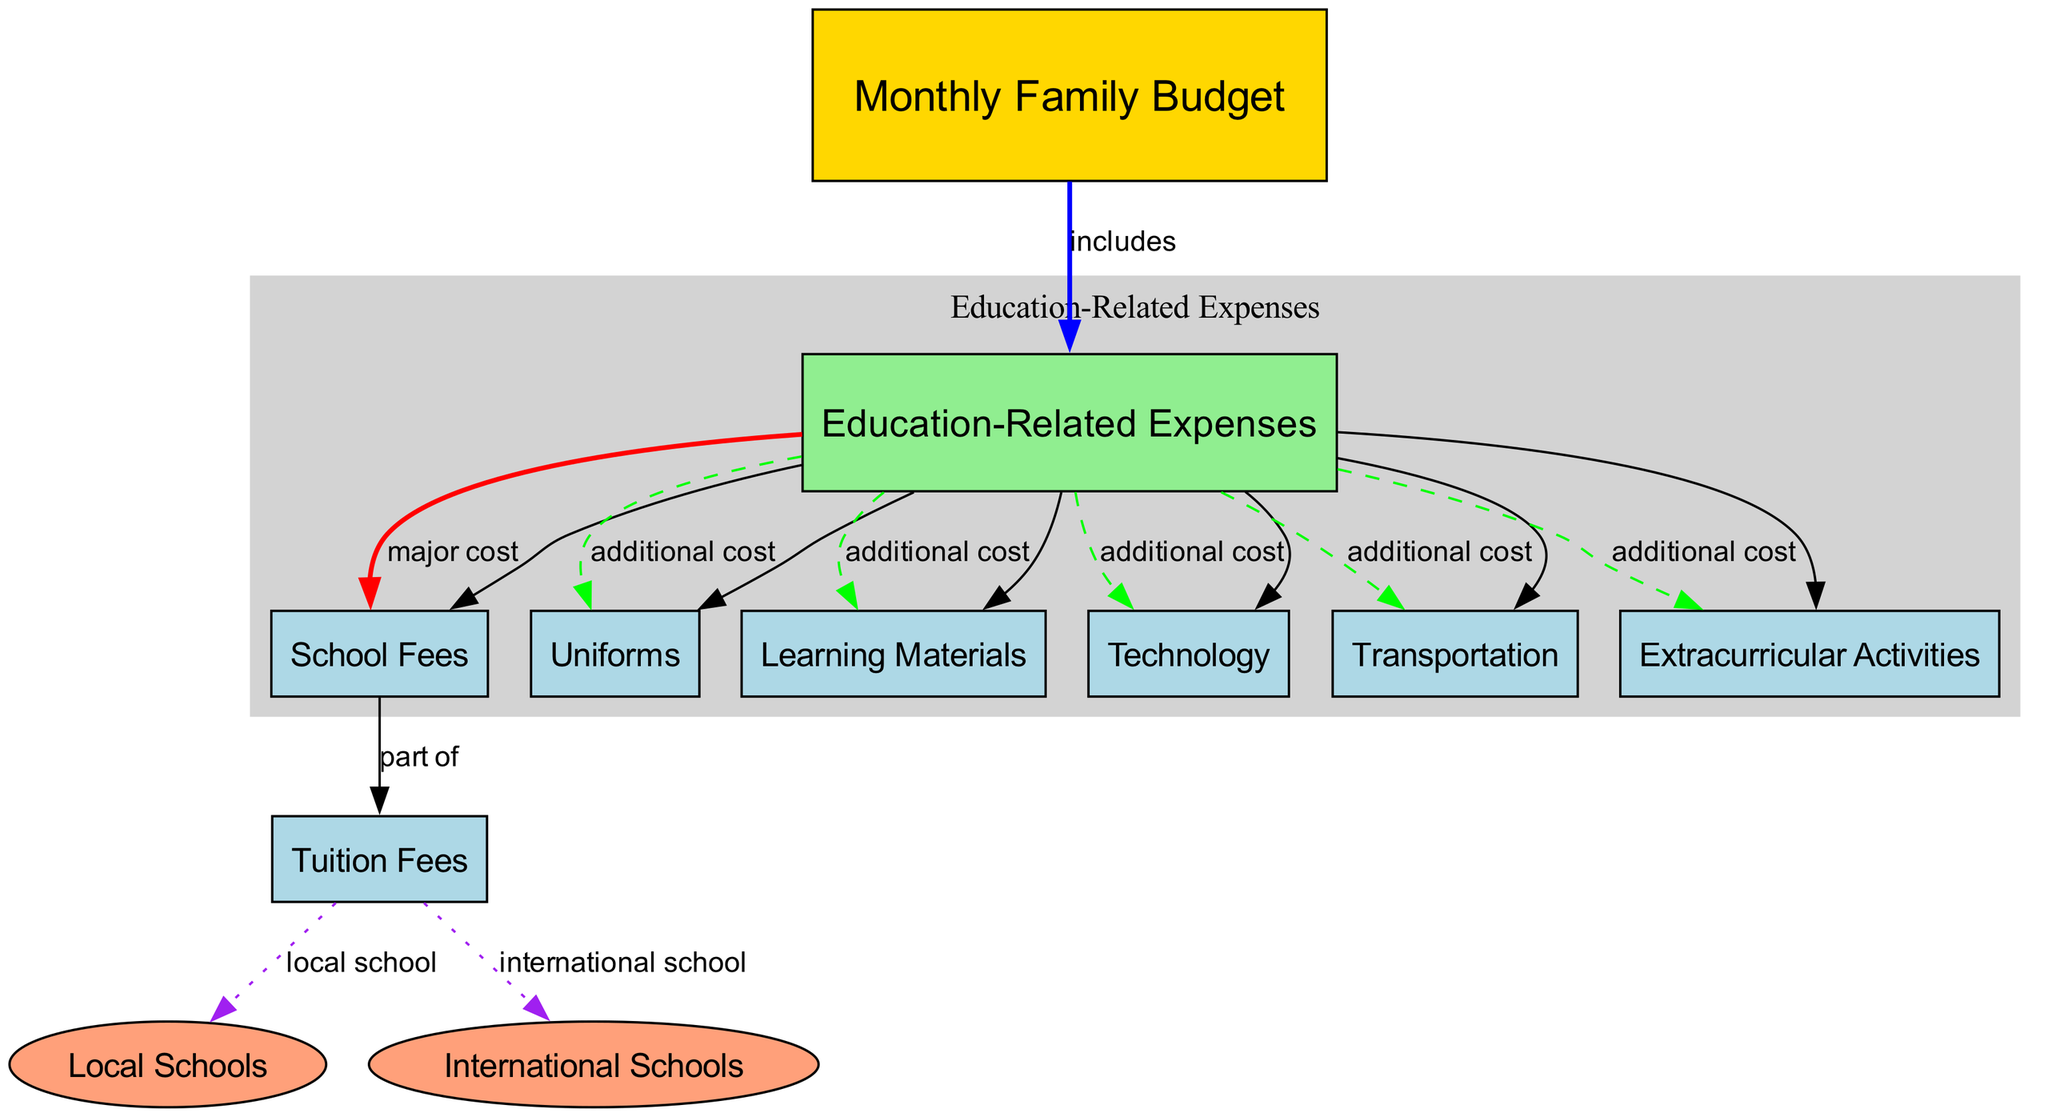What is included in the Monthly Family Budget? The diagram shows that the Monthly Family Budget includes Education-Related Expenses, as indicated by the edge labeled "includes" connecting the nodes for Monthly Family Budget and Education-Related Expenses.
Answer: Education-Related Expenses How many Education-Related Expenses are listed in the diagram? By counting the edges that connect to the Education-Related Expenses node, there are six distinct expenses listed: School Fees, Uniforms, Learning Materials, Technology, Transportation, and Extracurricular Activities.
Answer: Six What is the major cost under Education-Related Expenses? The diagram specifies that School Fees are labeled as the major cost under Education-Related Expenses, indicated by the edge labeled "major cost."
Answer: School Fees Which type of schools is connected to Tuition Fees? The diagram illustrates that Tuition Fees are part of both Local Schools and International Schools, as shown by the edges labeled "local school" and "international school" connecting to the Tuition Fees node.
Answer: Local Schools and International Schools What are the additional costs associated with Education-Related Expenses? The diagram lists five additional costs associated with Education-Related Expenses: Uniforms, Learning Materials, Technology, Transportation, and Extracurricular Activities.
Answer: Uniforms, Learning Materials, Technology, Transportation, Extracurricular Activities Why are International Schools and Local Schools shown in an ellipse shape? The diagram uses an ellipse shape to represent International Schools and Local Schools, which differentiates them from other expenses and indicates that they are secondary options tied to Tuition Fees.
Answer: To differentiate options How does the diagram classify School Fees? The diagram indicates that School Fees are a part of Education-Related Expenses and are classified as a major cost, as evidenced by the edge connecting them with the "part of" and "major cost" labels.
Answer: Major cost What color is used for nodes representing Education-Related Expenses in the diagram? The nodes that represent Education-Related Expenses are primarily colored light green, while the Monthly Family Budget node is colored gold, denoting different categories in the budget.
Answer: Light green What does the dashed line represent in the diagram? The dashed line represents additional costs associated with Education-Related Expenses, specifically connecting to nodes for Uniforms, Learning Materials, Technology, Transportation, and Extracurricular Activities.
Answer: Additional costs 